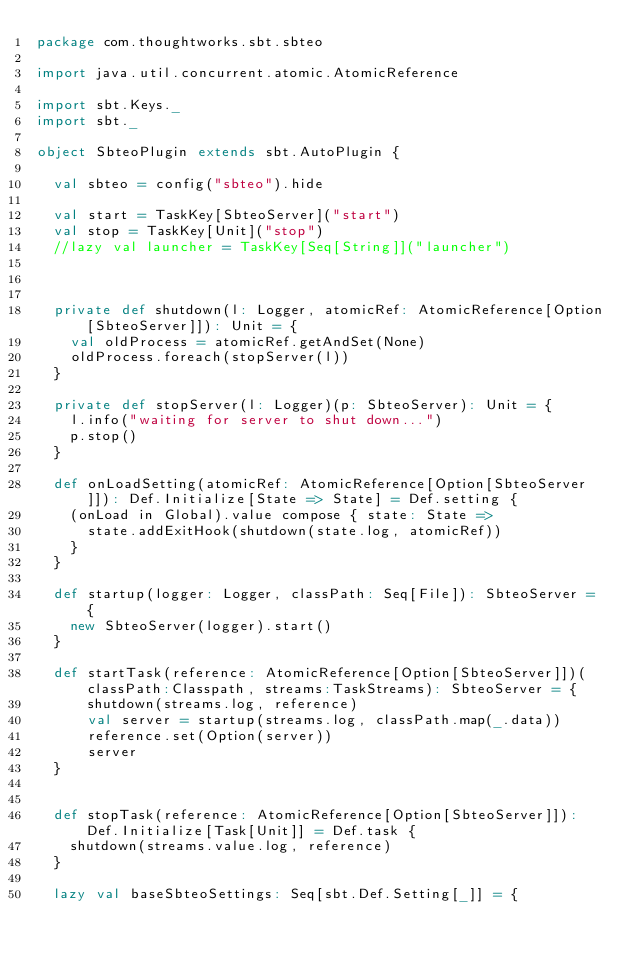<code> <loc_0><loc_0><loc_500><loc_500><_Scala_>package com.thoughtworks.sbt.sbteo

import java.util.concurrent.atomic.AtomicReference

import sbt.Keys._
import sbt._

object SbteoPlugin extends sbt.AutoPlugin {

  val sbteo = config("sbteo").hide

  val start = TaskKey[SbteoServer]("start")
  val stop = TaskKey[Unit]("stop")
  //lazy val launcher = TaskKey[Seq[String]]("launcher")



  private def shutdown(l: Logger, atomicRef: AtomicReference[Option[SbteoServer]]): Unit = {
    val oldProcess = atomicRef.getAndSet(None)
    oldProcess.foreach(stopServer(l))
  }

  private def stopServer(l: Logger)(p: SbteoServer): Unit = {
    l.info("waiting for server to shut down...")
    p.stop()
  }

  def onLoadSetting(atomicRef: AtomicReference[Option[SbteoServer]]): Def.Initialize[State => State] = Def.setting {
    (onLoad in Global).value compose { state: State =>
      state.addExitHook(shutdown(state.log, atomicRef))
    }
  }

  def startup(logger: Logger, classPath: Seq[File]): SbteoServer = {
    new SbteoServer(logger).start()
  }

  def startTask(reference: AtomicReference[Option[SbteoServer]])(classPath:Classpath, streams:TaskStreams): SbteoServer = {
      shutdown(streams.log, reference)
      val server = startup(streams.log, classPath.map(_.data))
      reference.set(Option(server))
      server
  }


  def stopTask(reference: AtomicReference[Option[SbteoServer]]): Def.Initialize[Task[Unit]] = Def.task {
    shutdown(streams.value.log, reference)
  }

  lazy val baseSbteoSettings: Seq[sbt.Def.Setting[_]] = {</code> 